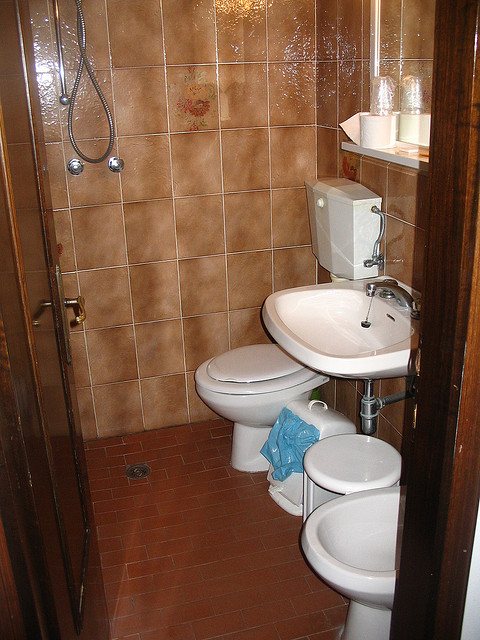Can you tell me what other bathroom fixtures are present in this image? Aside from the toilet, the bathroom features a bidet, a sink, and a shower. There's also a towel hanging near the bidet and a shelf above the sink holding toiletries. 